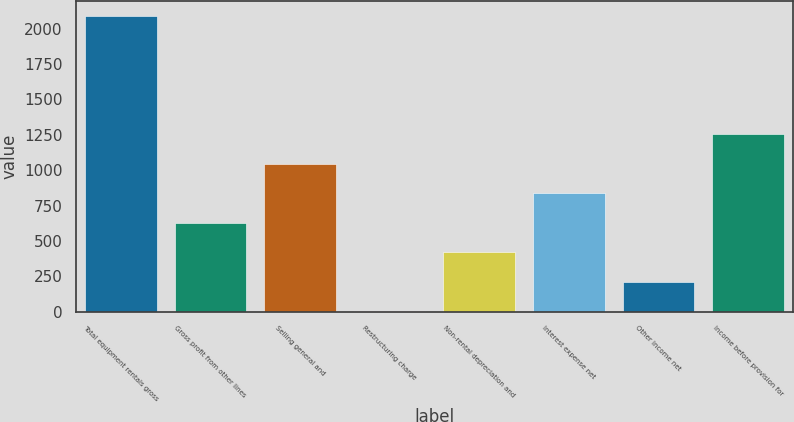Convert chart to OTSL. <chart><loc_0><loc_0><loc_500><loc_500><bar_chart><fcel>Total equipment rentals gross<fcel>Gross profit from other lines<fcel>Selling general and<fcel>Restructuring charge<fcel>Non-rental depreciation and<fcel>Interest expense net<fcel>Other income net<fcel>Income before provision for<nl><fcel>2092<fcel>628.3<fcel>1046.5<fcel>1<fcel>419.2<fcel>837.4<fcel>210.1<fcel>1255.6<nl></chart> 